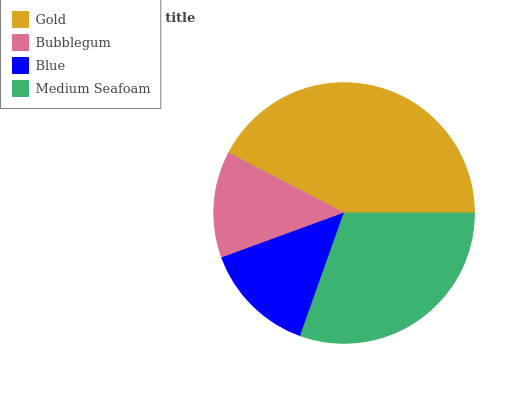Is Bubblegum the minimum?
Answer yes or no. Yes. Is Gold the maximum?
Answer yes or no. Yes. Is Blue the minimum?
Answer yes or no. No. Is Blue the maximum?
Answer yes or no. No. Is Blue greater than Bubblegum?
Answer yes or no. Yes. Is Bubblegum less than Blue?
Answer yes or no. Yes. Is Bubblegum greater than Blue?
Answer yes or no. No. Is Blue less than Bubblegum?
Answer yes or no. No. Is Medium Seafoam the high median?
Answer yes or no. Yes. Is Blue the low median?
Answer yes or no. Yes. Is Blue the high median?
Answer yes or no. No. Is Bubblegum the low median?
Answer yes or no. No. 